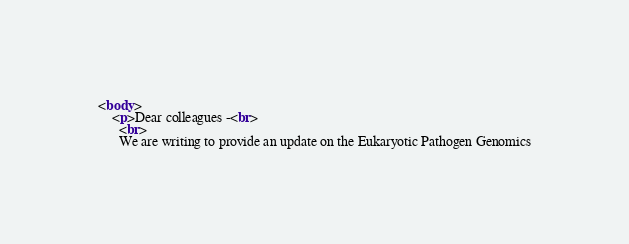Convert code to text. <code><loc_0><loc_0><loc_500><loc_500><_HTML_><body>
    <p>Dear colleagues -<br>
      <br>
      We are writing to provide an update on the Eukaryotic Pathogen Genomics</code> 